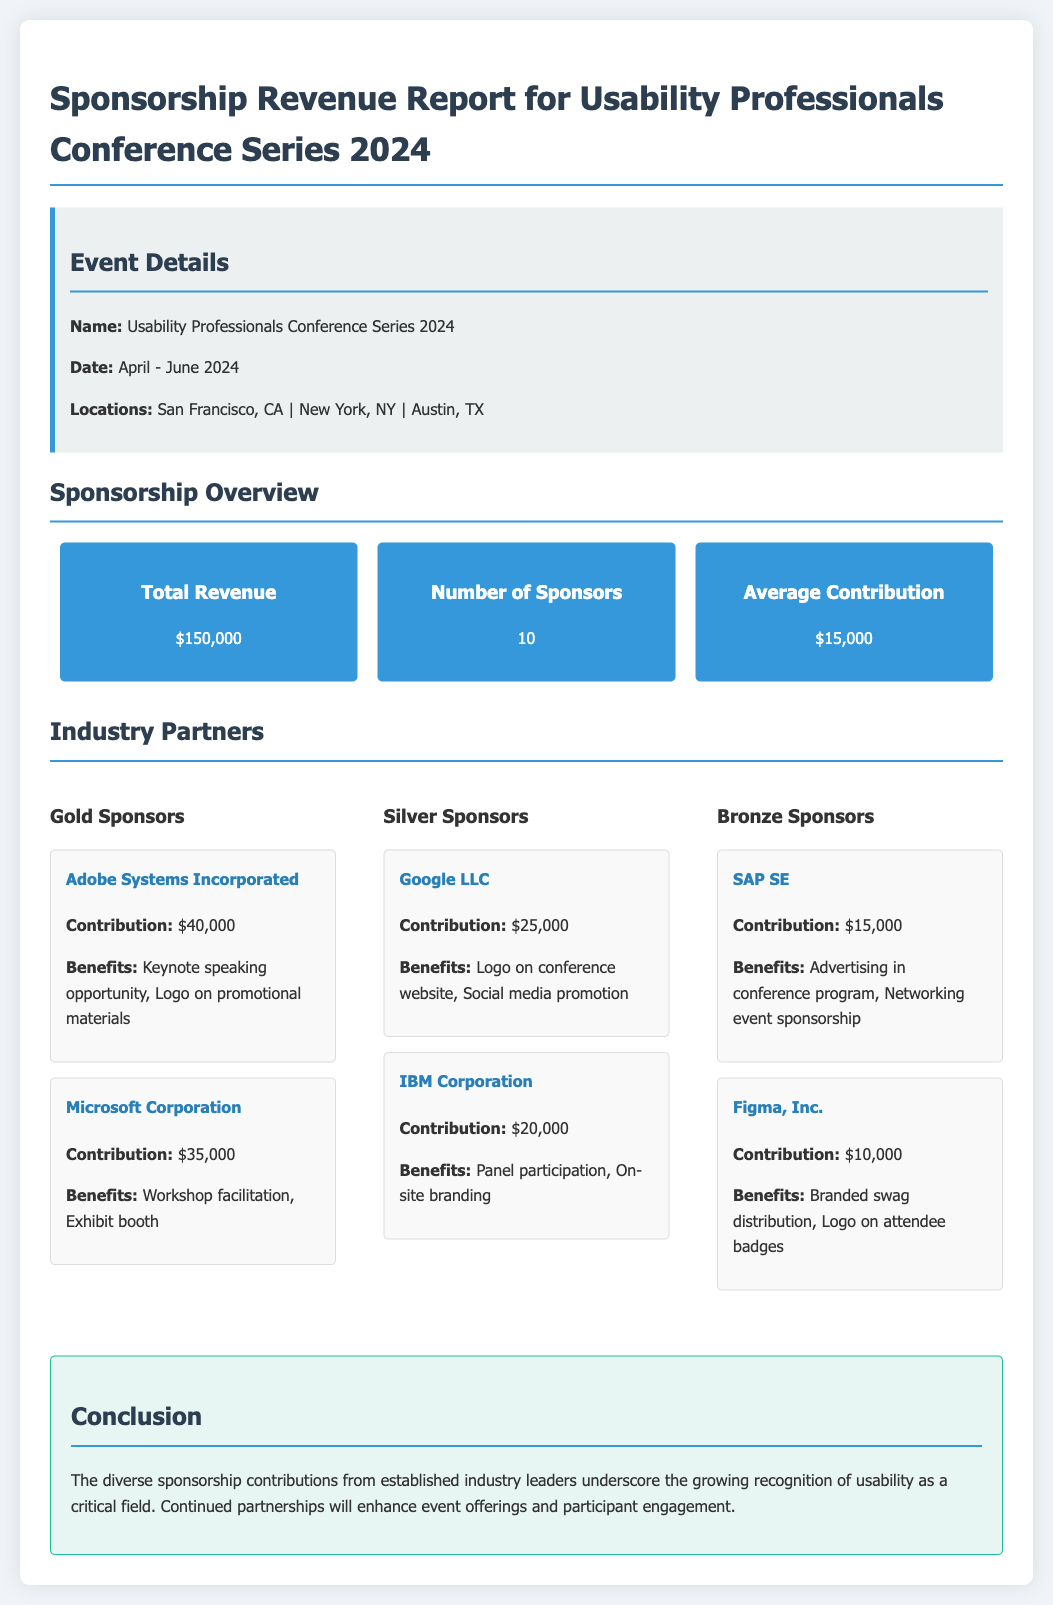What is the total revenue? The total revenue is explicitly mentioned as $150,000.
Answer: $150,000 How many sponsors are there? The document states that there are 10 sponsors involved in the event.
Answer: 10 What is the contribution of Adobe Systems Incorporated? The contribution from Adobe Systems Incorporated is specified as $40,000.
Answer: $40,000 What benefits does Microsoft Corporation receive? The benefits for Microsoft Corporation include workshop facilitation and an exhibit booth.
Answer: Workshop facilitation, Exhibit booth Which city will host the event? One of the cities hosting the event is New York, NY, as detailed in the event information.
Answer: New York, NY Who is the lowest contributing bronze sponsor? The lowest contributing bronze sponsor is Figma, Inc. with a contribution of $10,000.
Answer: Figma, Inc What is the average contribution? The average contribution is calculated as the total revenue divided by the number of sponsors, resulting in $15,000.
Answer: $15,000 What are the dates for the event series? The document specifies that the event will take place from April to June 2024.
Answer: April - June 2024 What is the largest sponsorship category? The largest sponsorship category is Gold Sponsors, which has higher contributions compared to the Silver and Bronze levels.
Answer: Gold Sponsors 